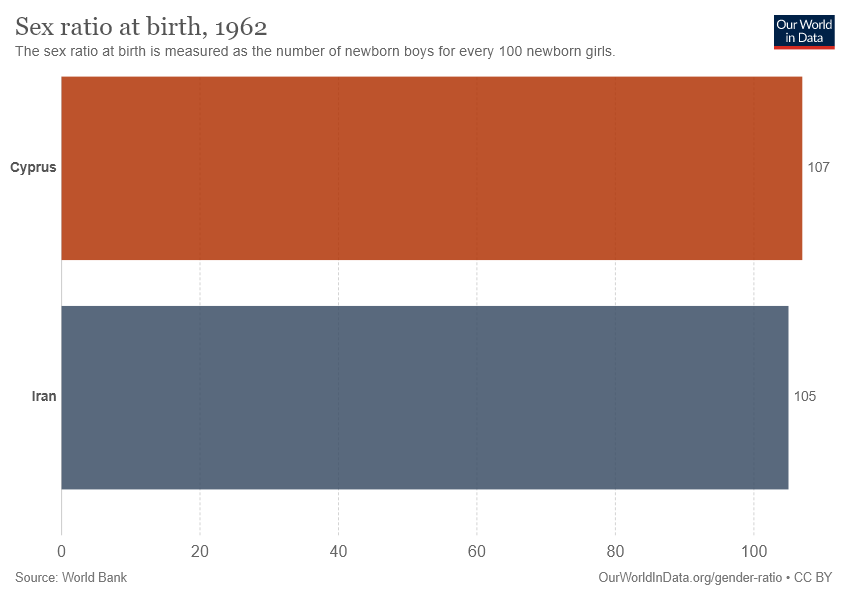Draw attention to some important aspects in this diagram. The difference in sex ratio at birth between two countries is 2. The grey bar represents Iran. 